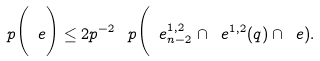Convert formula to latex. <formula><loc_0><loc_0><loc_500><loc_500>\ p \Big ( \ e \Big ) \leq 2 p ^ { - 2 } \, \ p \Big ( \ e ^ { 1 , 2 } _ { n - 2 } \cap \ e ^ { 1 , 2 } ( q ) \cap \ e ) .</formula> 